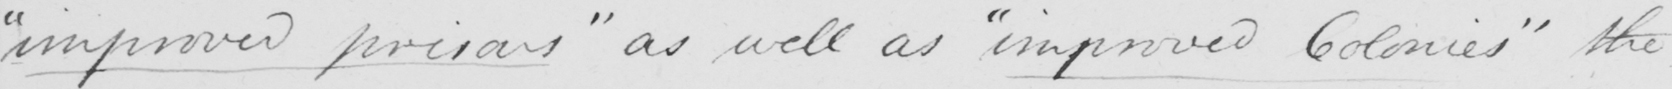Please transcribe the handwritten text in this image. " improved prisons "  as well as  " improved Colonies "  the 